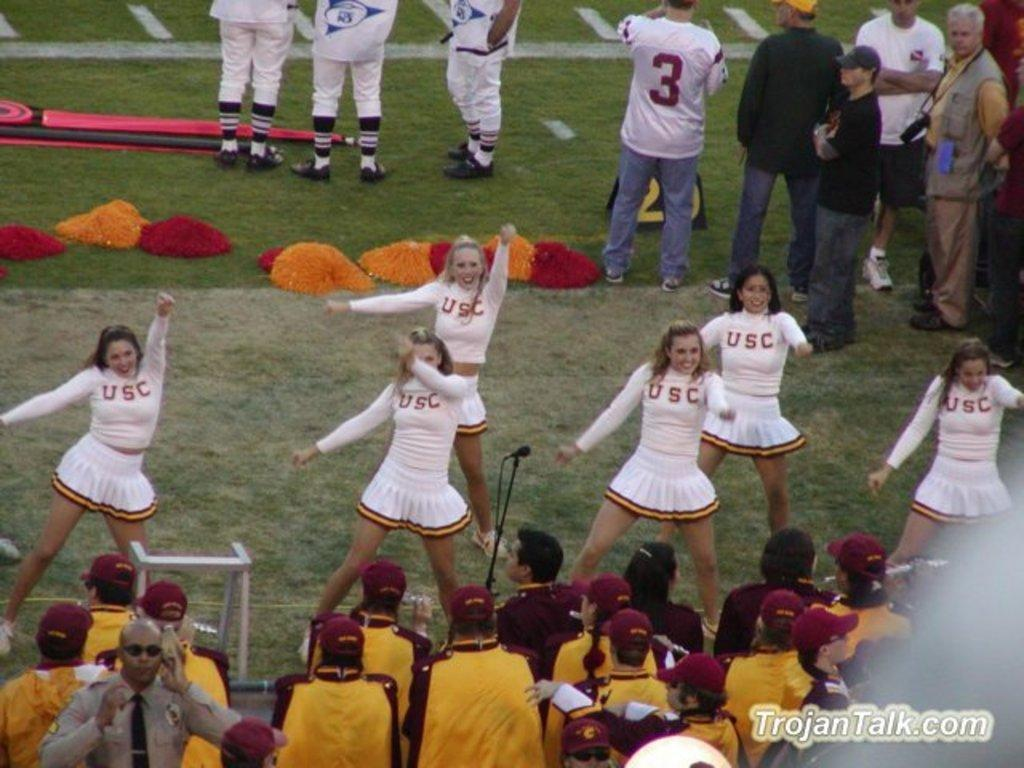<image>
Share a concise interpretation of the image provided. A group  of USC cheerleaders perform for a crowd at a football game 